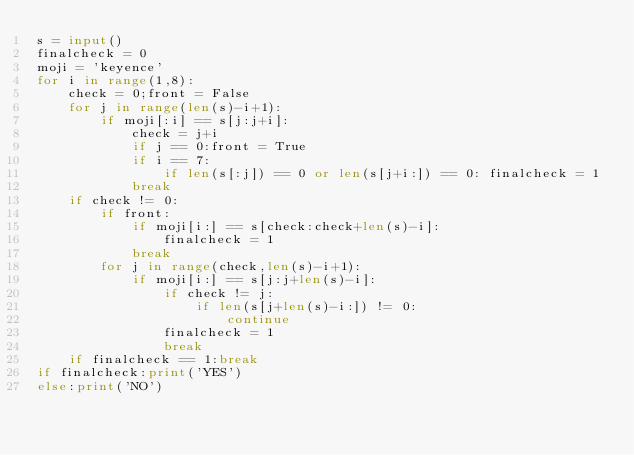Convert code to text. <code><loc_0><loc_0><loc_500><loc_500><_Python_>s = input()
finalcheck = 0
moji = 'keyence'
for i in range(1,8):
    check = 0;front = False
    for j in range(len(s)-i+1):
        if moji[:i] == s[j:j+i]:
            check = j+i
            if j == 0:front = True
            if i == 7:
                if len(s[:j]) == 0 or len(s[j+i:]) == 0: finalcheck = 1
            break
    if check != 0:
        if front:
            if moji[i:] == s[check:check+len(s)-i]:
                finalcheck = 1
            break
        for j in range(check,len(s)-i+1):
            if moji[i:] == s[j:j+len(s)-i]:
                if check != j:
                    if len(s[j+len(s)-i:]) != 0:
                        continue
                finalcheck = 1
                break
    if finalcheck == 1:break
if finalcheck:print('YES')
else:print('NO')</code> 